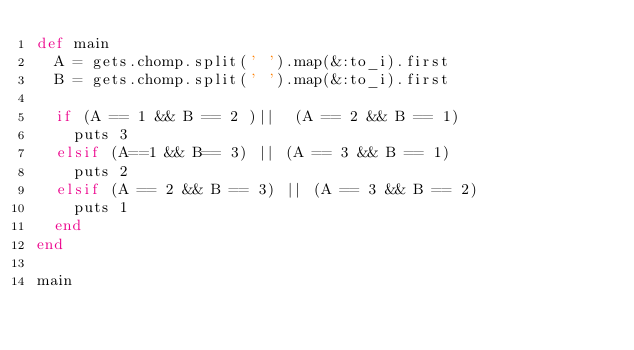Convert code to text. <code><loc_0><loc_0><loc_500><loc_500><_Ruby_>def main
  A = gets.chomp.split(' ').map(&:to_i).first
  B = gets.chomp.split(' ').map(&:to_i).first

  if (A == 1 && B == 2 )||  (A == 2 && B == 1)
    puts 3
  elsif (A==1 && B== 3) || (A == 3 && B == 1)
    puts 2
  elsif (A == 2 && B == 3) || (A == 3 && B == 2)
    puts 1
  end
end

main
</code> 